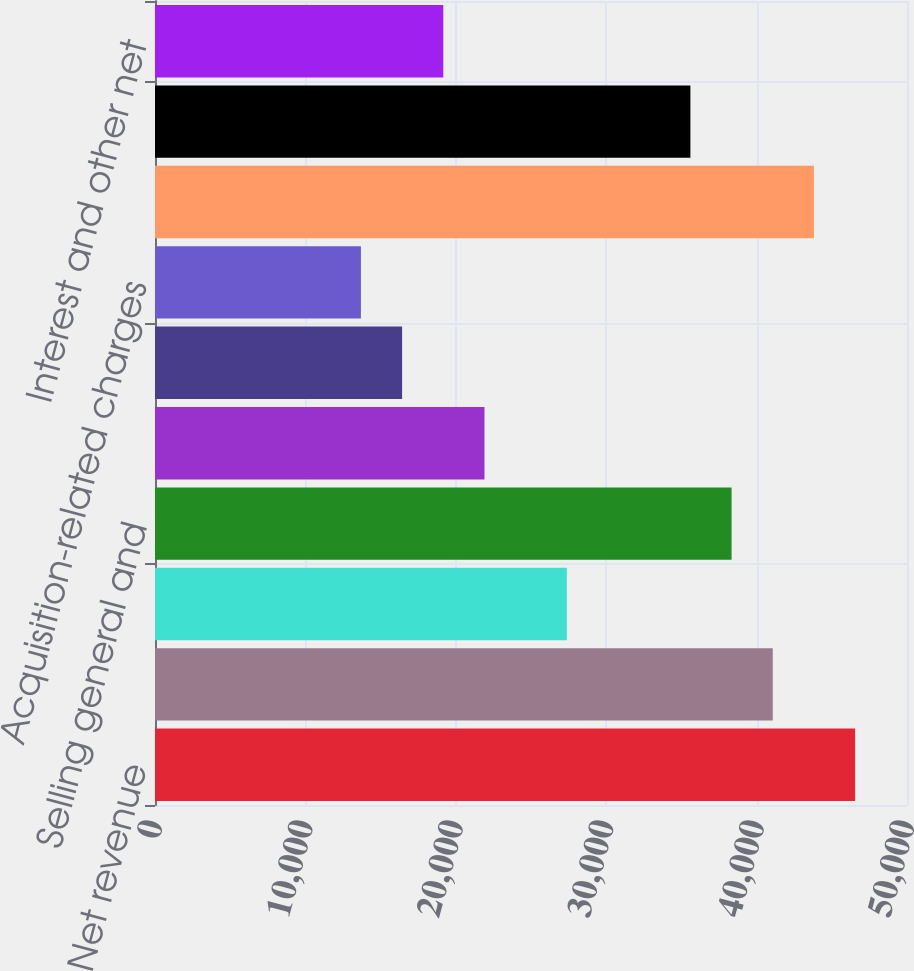Convert chart to OTSL. <chart><loc_0><loc_0><loc_500><loc_500><bar_chart><fcel>Net revenue<fcel>Cost of sales (1)<fcel>Research and development<fcel>Selling general and<fcel>Amortization of purchased<fcel>Restructuring charges<fcel>Acquisition-related charges<fcel>Total costs and expenses<fcel>Earnings from operations<fcel>Interest and other net<nl><fcel>46551<fcel>41074.4<fcel>27383<fcel>38336.1<fcel>21906.4<fcel>16429.8<fcel>13691.5<fcel>43812.7<fcel>35597.8<fcel>19168.1<nl></chart> 